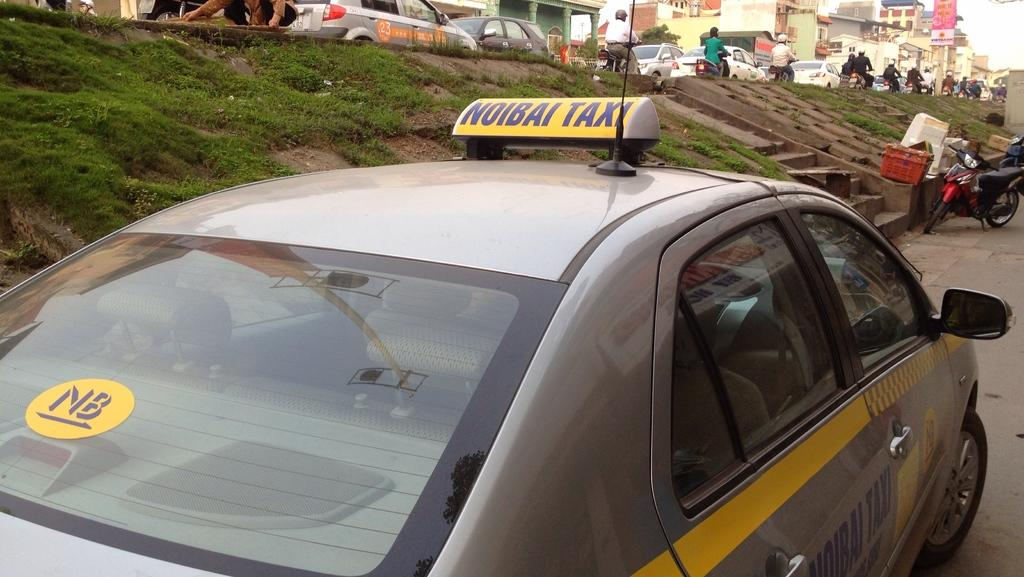What types of objects are present in the image? There are vehicles and people in the image. What is the ground like in the image? The ground is visible in the image. Are there any architectural features in the image? Yes, there are stairs in the image. What type of vegetation is present in the image? There is grass in the image. What part of the natural environment is visible in the image? The sky is visible in the image. What type of teaching is happening in the image? There is no teaching activity depicted in the image. Can you see a cat in the image? There is no cat present in the image. 